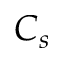Convert formula to latex. <formula><loc_0><loc_0><loc_500><loc_500>C _ { s }</formula> 